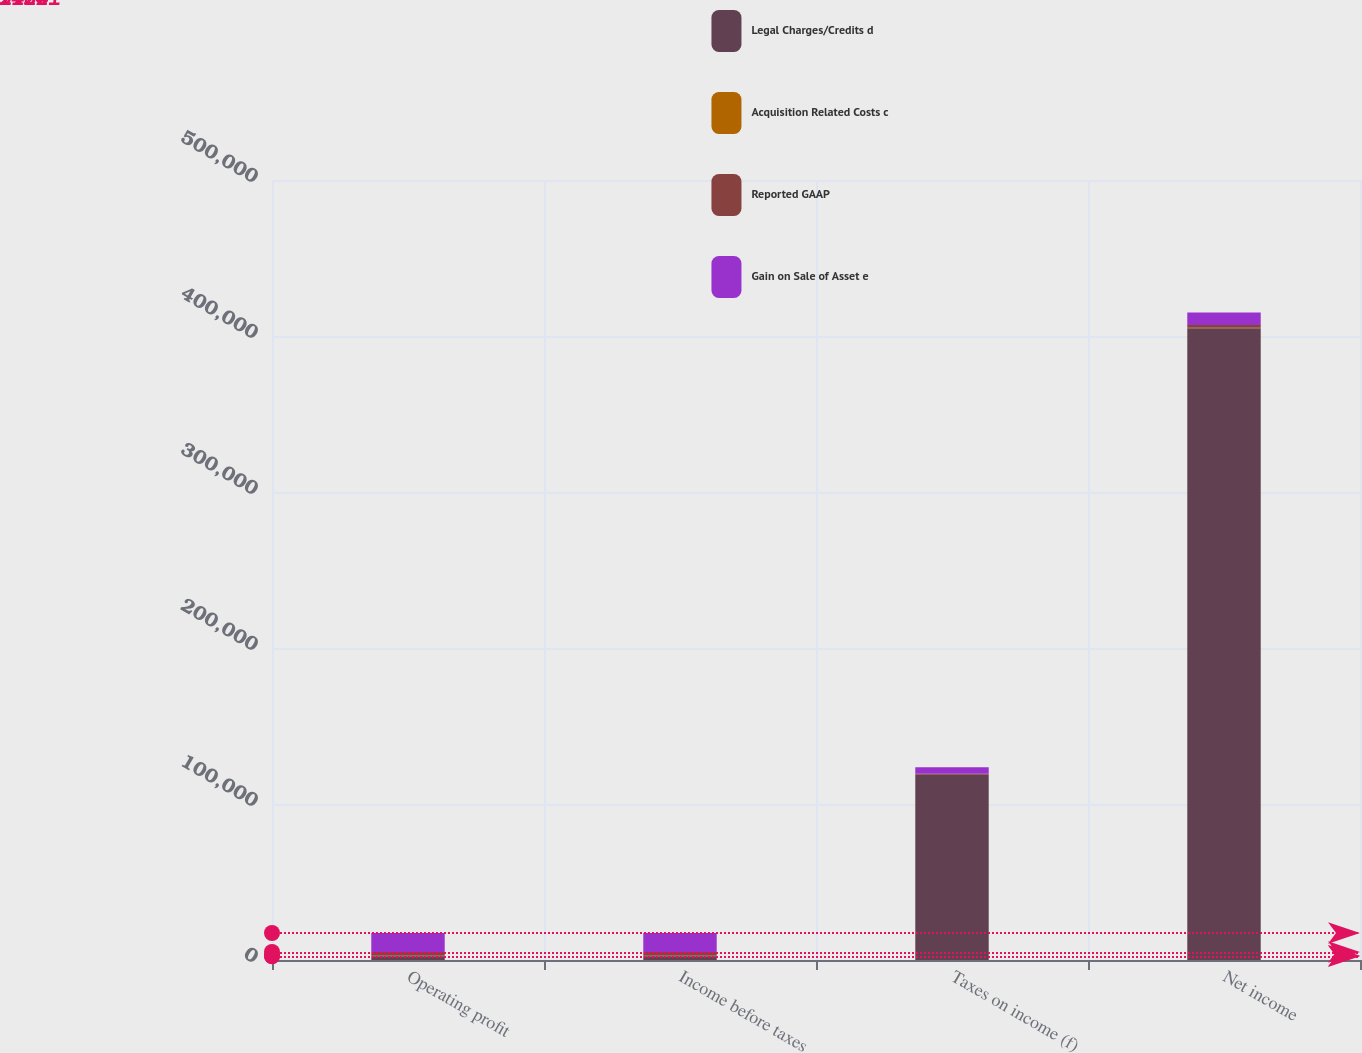Convert chart. <chart><loc_0><loc_0><loc_500><loc_500><stacked_bar_chart><ecel><fcel>Operating profit<fcel>Income before taxes<fcel>Taxes on income (f)<fcel>Net income<nl><fcel>Legal Charges/Credits d<fcel>2402<fcel>2402<fcel>118686<fcel>405031<nl><fcel>Acquisition Related Costs c<fcel>322<fcel>322<fcel>97<fcel>225<nl><fcel>Reported GAAP<fcel>2402<fcel>2402<fcel>599<fcel>1803<nl><fcel>Gain on Sale of Asset e<fcel>12195<fcel>12195<fcel>4117<fcel>8078<nl></chart> 